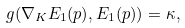Convert formula to latex. <formula><loc_0><loc_0><loc_500><loc_500>g ( \nabla _ { K } E _ { 1 } ( p ) , E _ { 1 } ( p ) ) = \kappa ,</formula> 